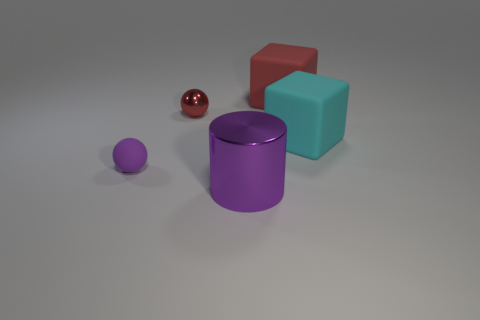Add 1 small red things. How many objects exist? 6 Subtract all cyan cubes. How many cubes are left? 1 Subtract all blocks. How many objects are left? 3 Subtract all tiny yellow rubber balls. Subtract all purple balls. How many objects are left? 4 Add 5 large purple metallic things. How many large purple metallic things are left? 6 Add 3 tiny matte cubes. How many tiny matte cubes exist? 3 Subtract 1 purple cylinders. How many objects are left? 4 Subtract 1 balls. How many balls are left? 1 Subtract all brown blocks. Subtract all red cylinders. How many blocks are left? 2 Subtract all cyan cubes. How many red cylinders are left? 0 